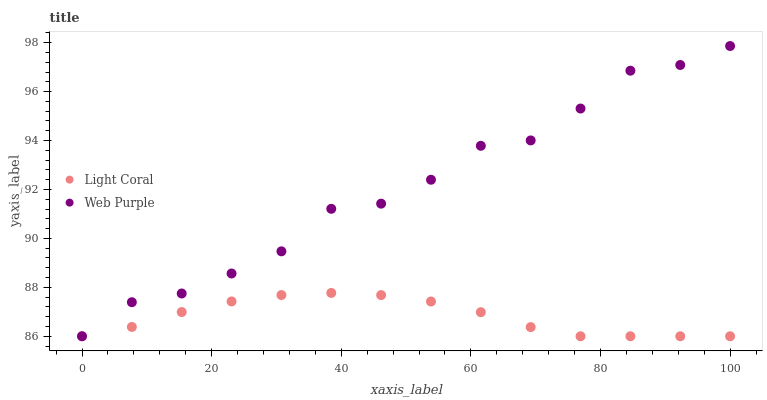Does Light Coral have the minimum area under the curve?
Answer yes or no. Yes. Does Web Purple have the maximum area under the curve?
Answer yes or no. Yes. Does Web Purple have the minimum area under the curve?
Answer yes or no. No. Is Light Coral the smoothest?
Answer yes or no. Yes. Is Web Purple the roughest?
Answer yes or no. Yes. Is Web Purple the smoothest?
Answer yes or no. No. Does Light Coral have the lowest value?
Answer yes or no. Yes. Does Web Purple have the highest value?
Answer yes or no. Yes. Does Light Coral intersect Web Purple?
Answer yes or no. Yes. Is Light Coral less than Web Purple?
Answer yes or no. No. Is Light Coral greater than Web Purple?
Answer yes or no. No. 